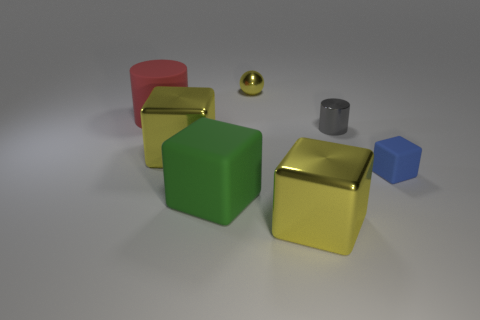Can you describe the lighting and shadows in the scene? Certainly! The lighting in the scene is soft and diffused, creating gentle shadows to the right of the objects. This suggests the light source is coming from the left side, probably a bit elevated. The shadows give a sense of depth and contribute to the realism of the scene. 